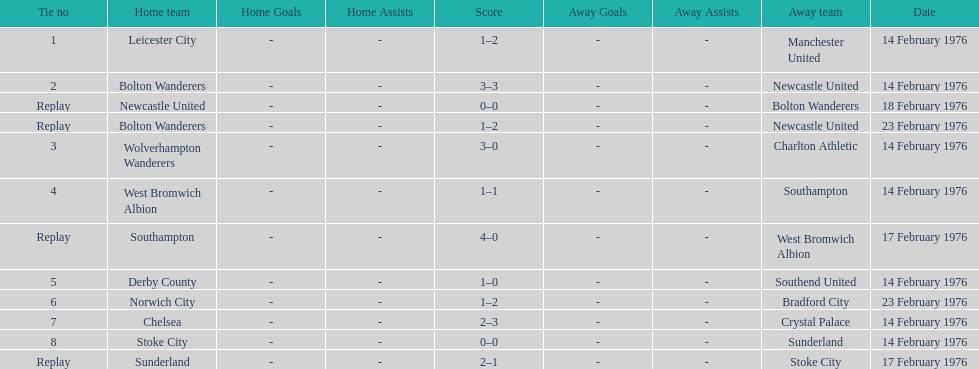Which teams played the same day as leicester city and manchester united? Bolton Wanderers, Newcastle United. 